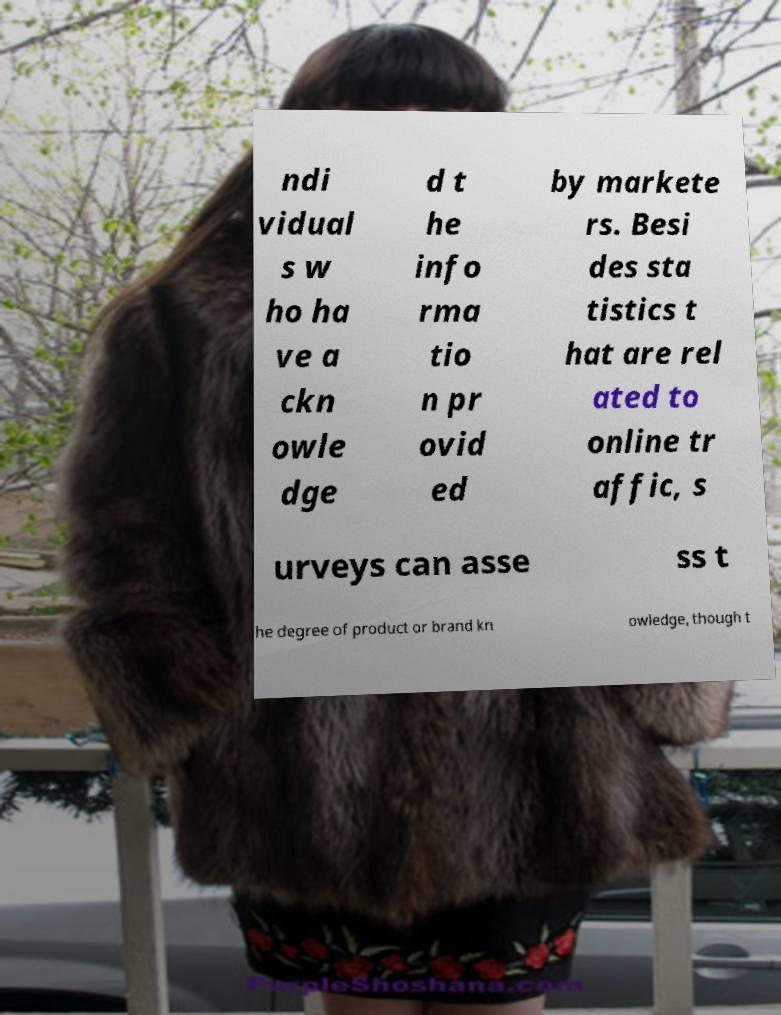Please identify and transcribe the text found in this image. ndi vidual s w ho ha ve a ckn owle dge d t he info rma tio n pr ovid ed by markete rs. Besi des sta tistics t hat are rel ated to online tr affic, s urveys can asse ss t he degree of product or brand kn owledge, though t 